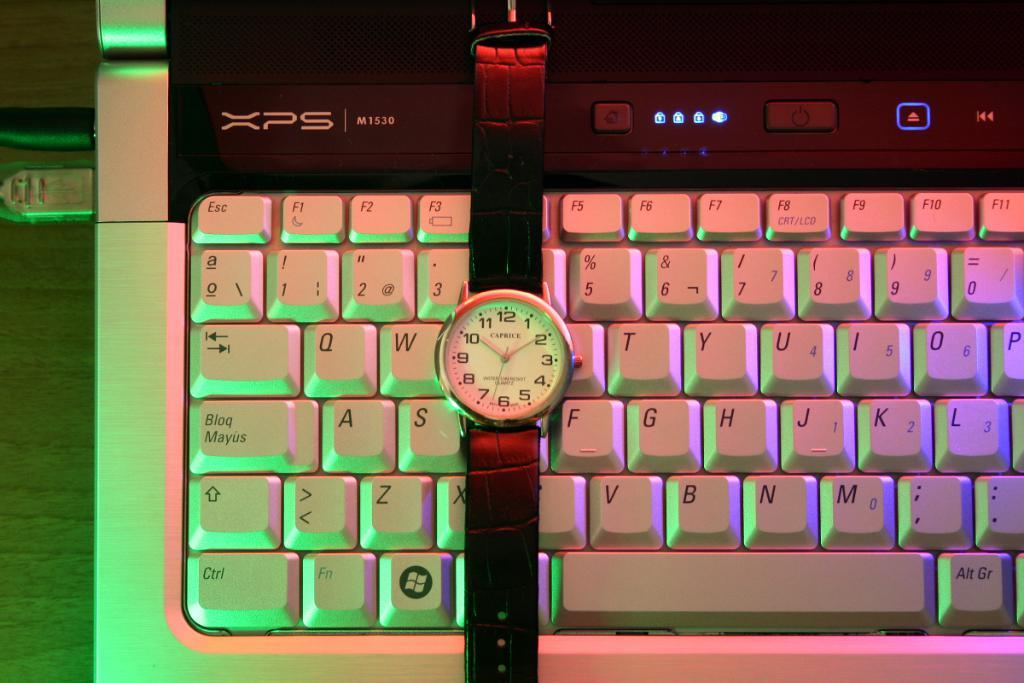<image>
Create a compact narrative representing the image presented. A watch on a keyboard says "CAPRICE" on the face. 